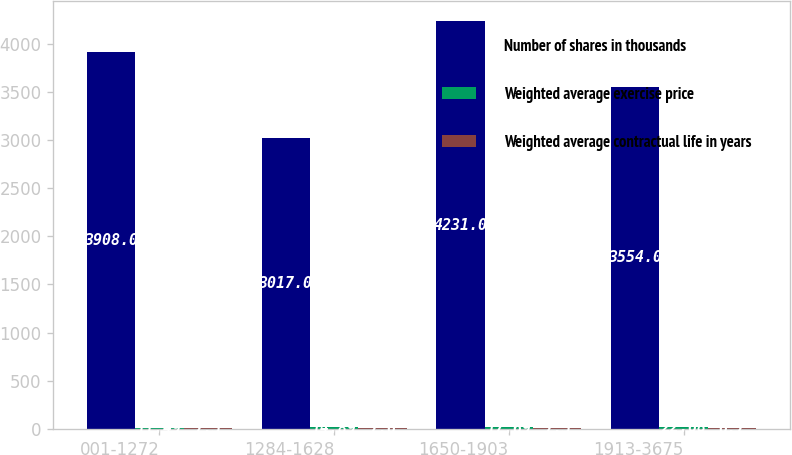<chart> <loc_0><loc_0><loc_500><loc_500><stacked_bar_chart><ecel><fcel>001-1272<fcel>1284-1628<fcel>1650-1903<fcel>1913-3675<nl><fcel>Number of shares in thousands<fcel>3908<fcel>3017<fcel>4231<fcel>3554<nl><fcel>Weighted average exercise price<fcel>11.49<fcel>14.89<fcel>17.69<fcel>22.68<nl><fcel>Weighted average contractual life in years<fcel>7.5<fcel>7.6<fcel>7.5<fcel>6.7<nl></chart> 